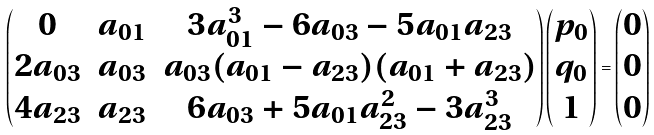<formula> <loc_0><loc_0><loc_500><loc_500>\begin{pmatrix} 0 & a _ { 0 1 } & 3 a _ { 0 1 } ^ { 3 } - 6 a _ { 0 3 } - 5 a _ { 0 1 } a _ { 2 3 } \\ 2 a _ { 0 3 } & a _ { 0 3 } & a _ { 0 3 } ( a _ { 0 1 } - a _ { 2 3 } ) ( a _ { 0 1 } + a _ { 2 3 } ) \\ 4 a _ { 2 3 } & a _ { 2 3 } & 6 a _ { 0 3 } + 5 a _ { 0 1 } a _ { 2 3 } ^ { 2 } - 3 a _ { 2 3 } ^ { 3 } \end{pmatrix} \begin{pmatrix} p _ { 0 } \\ q _ { 0 } \\ 1 \end{pmatrix} = \begin{pmatrix} 0 \\ 0 \\ 0 \end{pmatrix}</formula> 